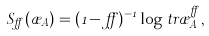<formula> <loc_0><loc_0><loc_500><loc_500>S _ { \alpha } ( \rho _ { A } ) = ( 1 - \alpha ) ^ { - 1 } \log t r \rho _ { A } ^ { \alpha } ,</formula> 